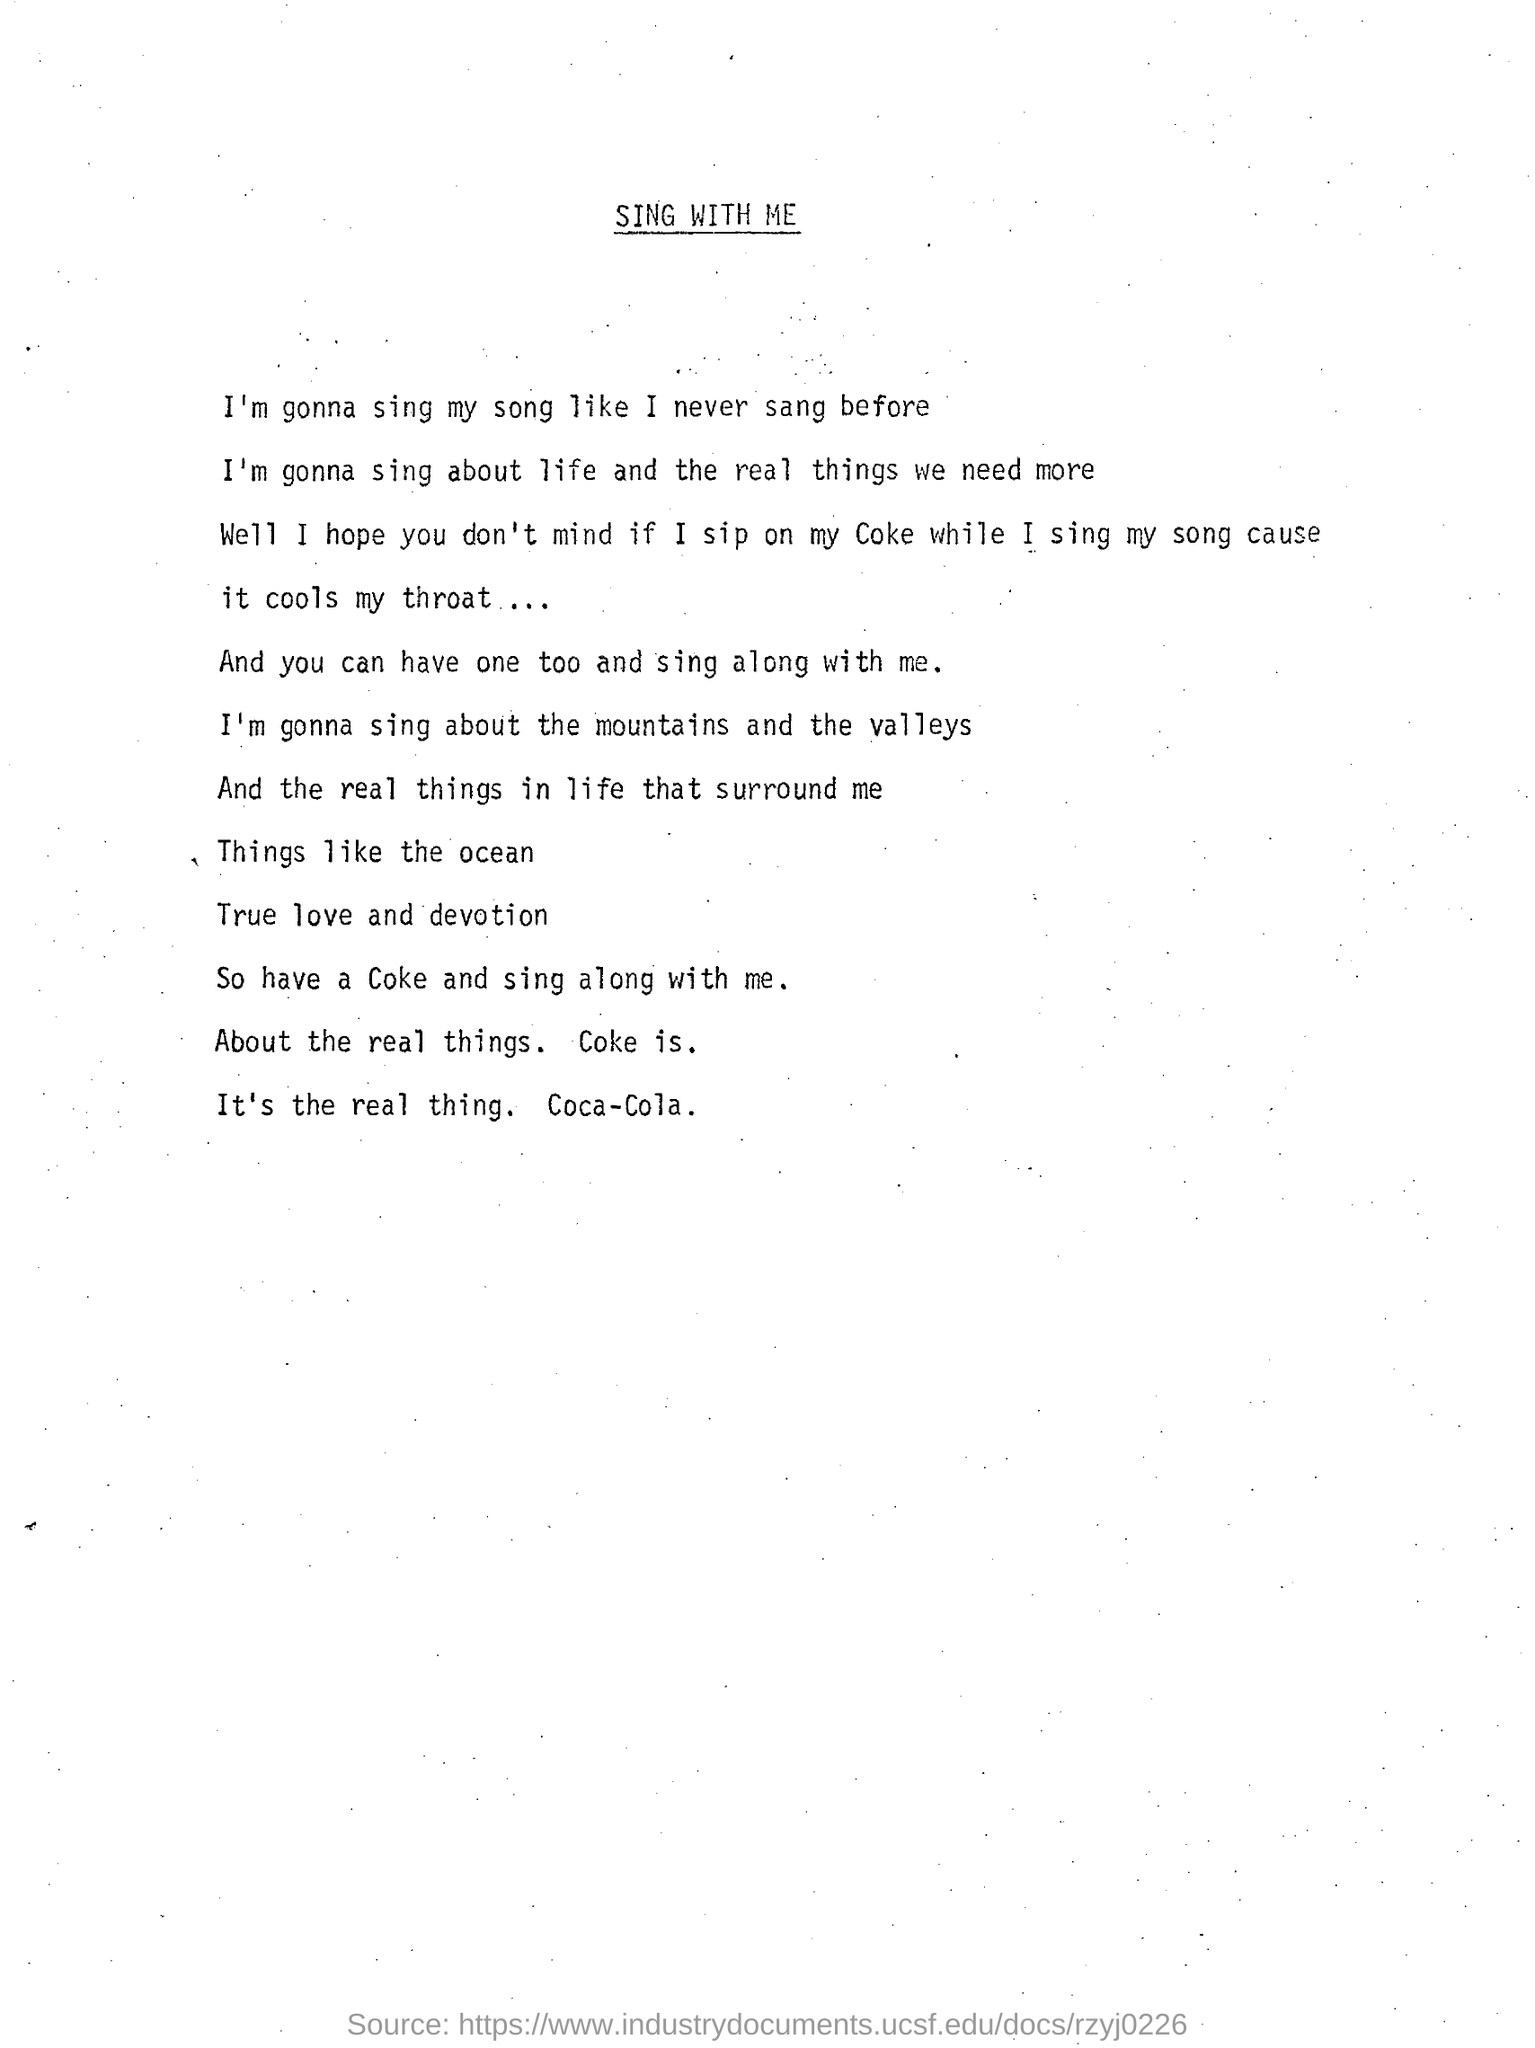What is the title of the page?
Make the answer very short. Sing With Me. What happens if i sip on my coke while i sing my song according to letter?
Provide a succinct answer. It cools my throat. 